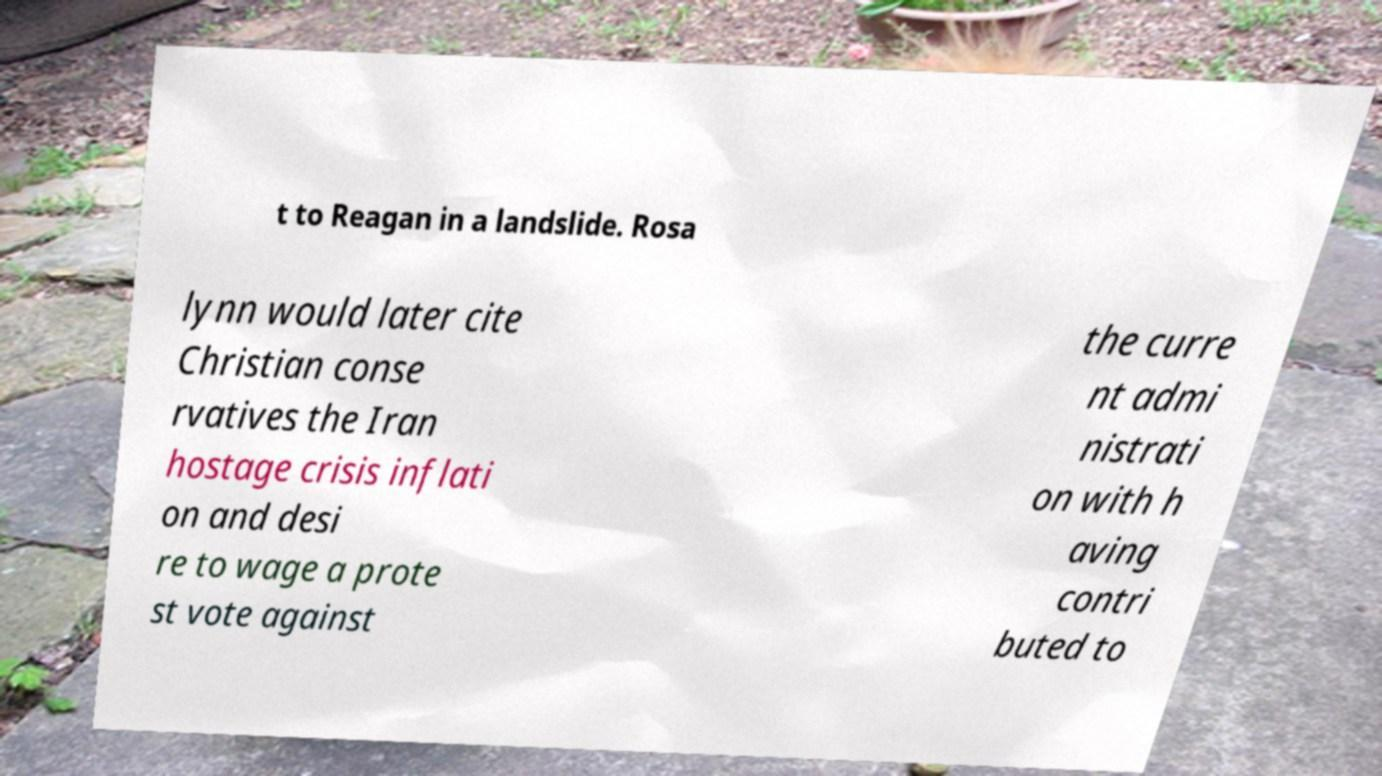Can you read and provide the text displayed in the image?This photo seems to have some interesting text. Can you extract and type it out for me? t to Reagan in a landslide. Rosa lynn would later cite Christian conse rvatives the Iran hostage crisis inflati on and desi re to wage a prote st vote against the curre nt admi nistrati on with h aving contri buted to 